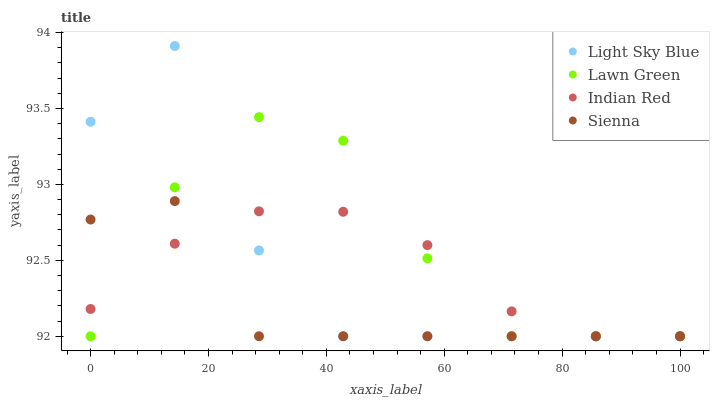Does Sienna have the minimum area under the curve?
Answer yes or no. Yes. Does Lawn Green have the maximum area under the curve?
Answer yes or no. Yes. Does Light Sky Blue have the minimum area under the curve?
Answer yes or no. No. Does Light Sky Blue have the maximum area under the curve?
Answer yes or no. No. Is Indian Red the smoothest?
Answer yes or no. Yes. Is Light Sky Blue the roughest?
Answer yes or no. Yes. Is Lawn Green the smoothest?
Answer yes or no. No. Is Lawn Green the roughest?
Answer yes or no. No. Does Sienna have the lowest value?
Answer yes or no. Yes. Does Light Sky Blue have the highest value?
Answer yes or no. Yes. Does Lawn Green have the highest value?
Answer yes or no. No. Does Lawn Green intersect Sienna?
Answer yes or no. Yes. Is Lawn Green less than Sienna?
Answer yes or no. No. Is Lawn Green greater than Sienna?
Answer yes or no. No. 